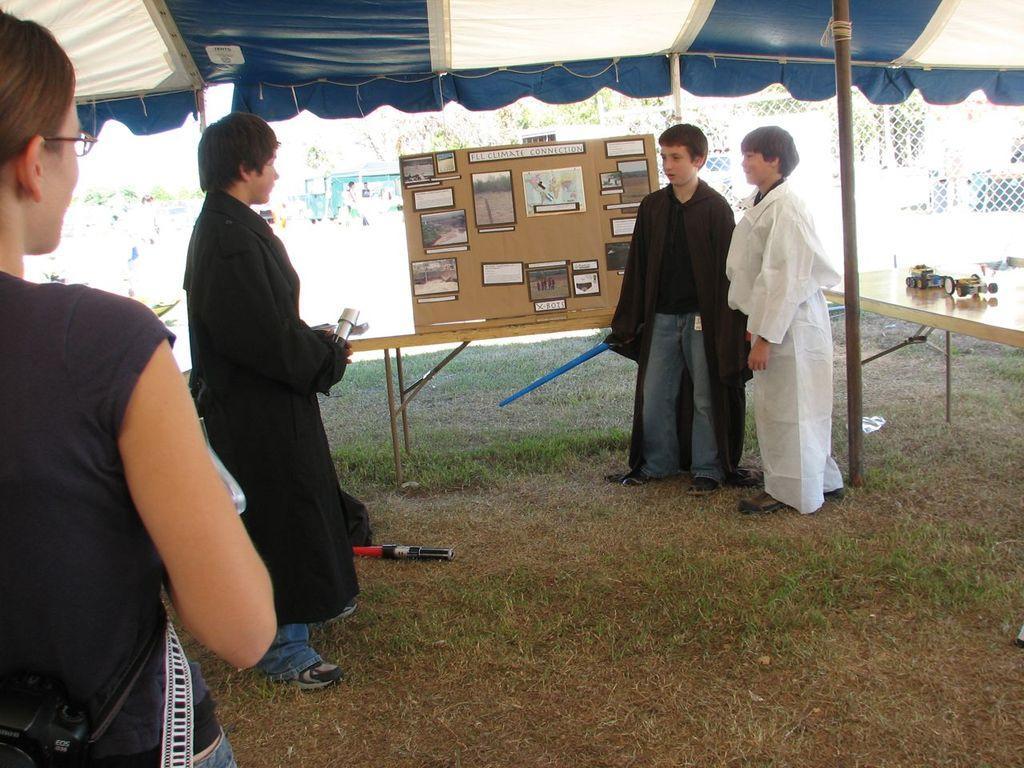In one or two sentences, can you explain what this image depicts? In this image I can see four people standing under the tent. I can see these people are wearing the white, black and blue color dresses. To the side of these people I can see the board. To the right I can see some objects on the table. I can see two people are holding some objects. In the background I can see few more people, trees and the railing. 